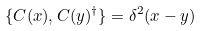Convert formula to latex. <formula><loc_0><loc_0><loc_500><loc_500>\{ C ( x ) , C ( y ) ^ { \dagger } \} = \delta ^ { 2 } ( x - y )</formula> 